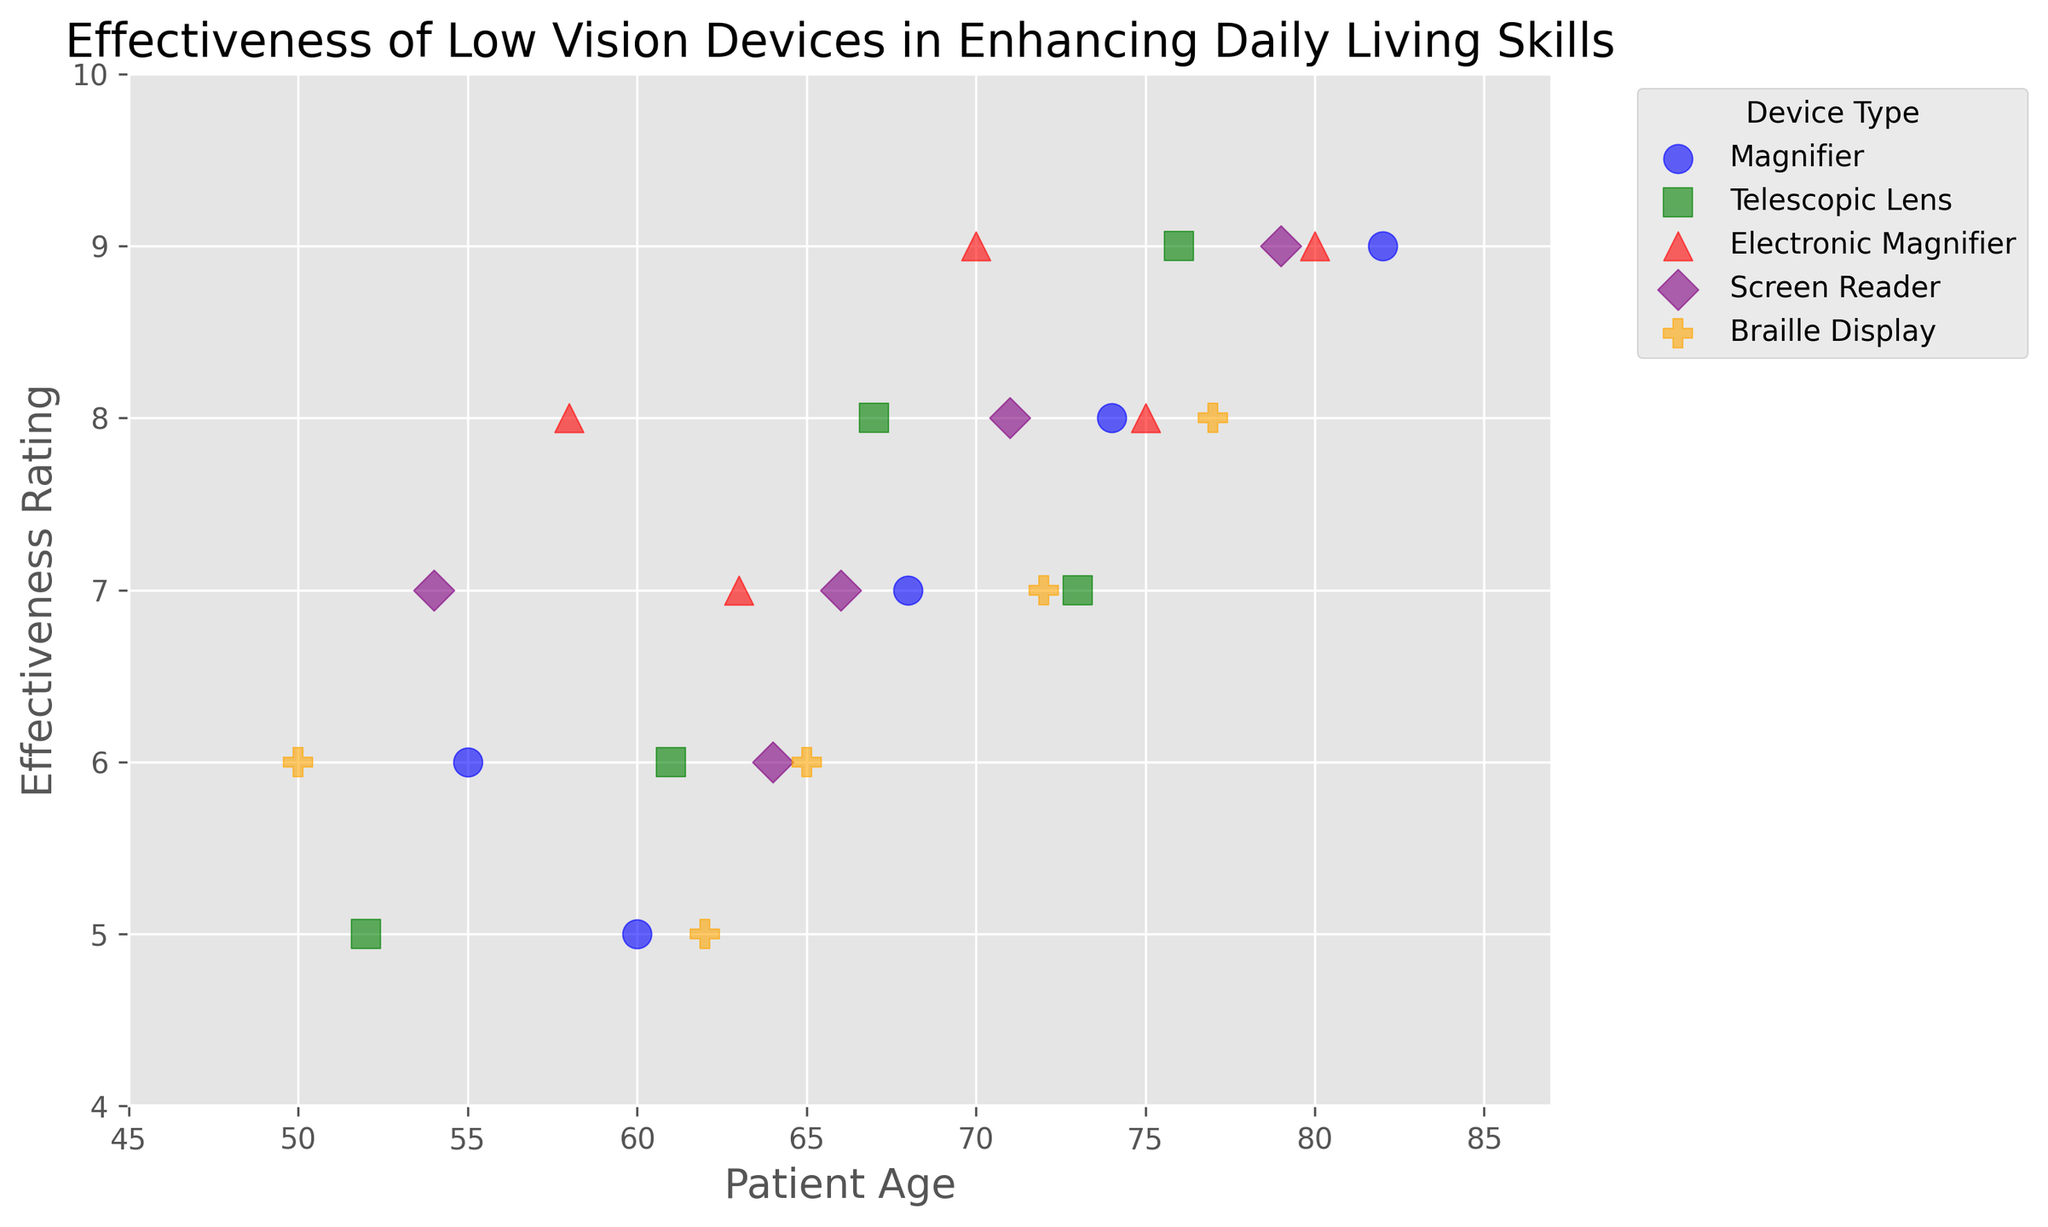Which device has the highest effectiveness rating for patients aged 79? First, locate the data points for patients aged 79. Then, check the effectiveness ratings associated with each device type for these patients. The highest rating for a patient aged 79 corresponds to a Screen Reader, with a rating of 9.
Answer: Screen Reader What is the average effectiveness rating of the Magnifier device? Add up all the effectiveness ratings for the Magnifier device and divide by the number of data points: (7 + 8 + 5 + 9 + 6) = 35. There are 5 data points, so the average is 35 / 5 = 7.
Answer: 7 Which device appears to be the most consistently effective across different ages, based on the spread of points? Look at the scatter points' spread for each device. Telescopic Lens and Electronic Magnifier show a narrower spread in effectiveness ratings across different ages, indicating more consistent effectiveness. Both devices have ratings between 6 and 9.
Answer: Telescopic Lens and Electronic Magnifier Is there any device that has the same effectiveness rating for patients of different ages? If so, which ones? Check the effectiveness ratings for each device to see if there are any repeats across different ages. The Electronic Magnifier, for instance, has an effectiveness rating of 9 for patients aged 70 and 80.
Answer: Electronic Magnifier Which device has the lowest effectiveness rating for the youngest age group (age 50)? Identify the data point for age 50 and check the corresponding effectiveness rating and device. The lowest rating for age 50 is 6 for Braille Display.
Answer: Braille Display How does the effectiveness rating of Telescopic Lens for the patient age 61 compare to the other devices for the same age? Check the effectiveness rating for Telescopic Lens at age 61 (which is 6) and compare it to the effectiveness ratings of other devices at the same age. The effectiveness ratings for other devices at age 61 are not provided in the exact data snippet, but Braille Display closely matches at the age 62 with a similar pattern of lower ratings compared to others.
Answer: The rating is similar to that of Braille Display at a close age What is the highest effectiveness rating for Electronic Magnifiers and at what ages does it occur? Identify all the effectiveness ratings for Electronic Magnifier and note the ages where the highest rating occurs. The highest rating is 9, and it occurs at ages 70 and 80.
Answer: 9 for ages 70 and 80 How does the effectiveness rating of the Screen Reader for the patients aged 64 compare to that of Braille Display? Compare the effectiveness rating for Screen Reader at age 64 (which is 6) to that of Braille Display at age 62 (which is 5) and nearby ages. Screen Reader's rating is slightly higher.
Answer: Screen Reader is higher 